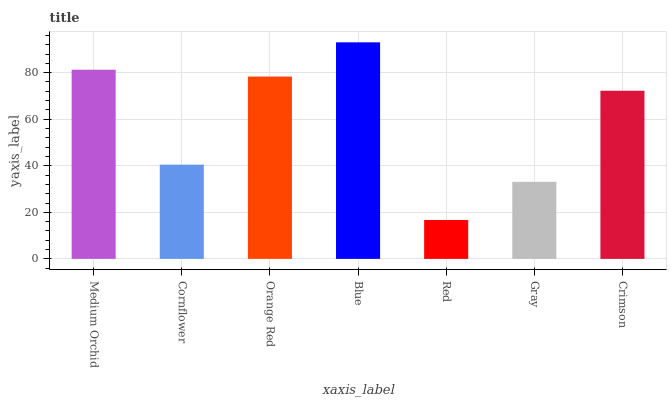Is Red the minimum?
Answer yes or no. Yes. Is Blue the maximum?
Answer yes or no. Yes. Is Cornflower the minimum?
Answer yes or no. No. Is Cornflower the maximum?
Answer yes or no. No. Is Medium Orchid greater than Cornflower?
Answer yes or no. Yes. Is Cornflower less than Medium Orchid?
Answer yes or no. Yes. Is Cornflower greater than Medium Orchid?
Answer yes or no. No. Is Medium Orchid less than Cornflower?
Answer yes or no. No. Is Crimson the high median?
Answer yes or no. Yes. Is Crimson the low median?
Answer yes or no. Yes. Is Medium Orchid the high median?
Answer yes or no. No. Is Red the low median?
Answer yes or no. No. 